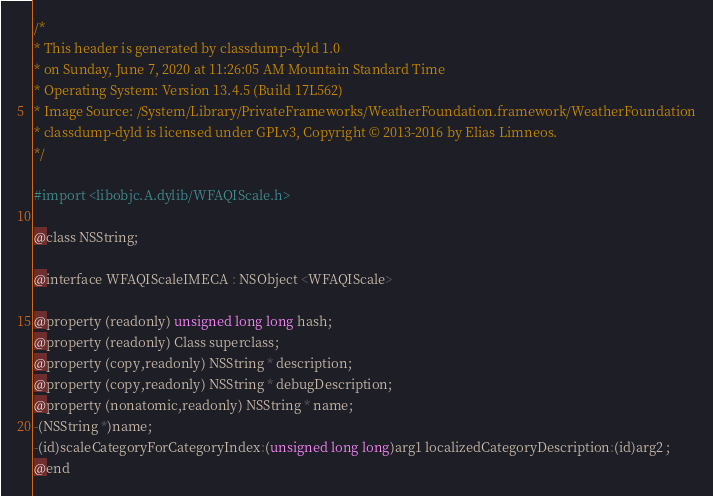Convert code to text. <code><loc_0><loc_0><loc_500><loc_500><_C_>/*
* This header is generated by classdump-dyld 1.0
* on Sunday, June 7, 2020 at 11:26:05 AM Mountain Standard Time
* Operating System: Version 13.4.5 (Build 17L562)
* Image Source: /System/Library/PrivateFrameworks/WeatherFoundation.framework/WeatherFoundation
* classdump-dyld is licensed under GPLv3, Copyright © 2013-2016 by Elias Limneos.
*/

#import <libobjc.A.dylib/WFAQIScale.h>

@class NSString;

@interface WFAQIScaleIMECA : NSObject <WFAQIScale>

@property (readonly) unsigned long long hash; 
@property (readonly) Class superclass; 
@property (copy,readonly) NSString * description; 
@property (copy,readonly) NSString * debugDescription; 
@property (nonatomic,readonly) NSString * name; 
-(NSString *)name;
-(id)scaleCategoryForCategoryIndex:(unsigned long long)arg1 localizedCategoryDescription:(id)arg2 ;
@end

</code> 